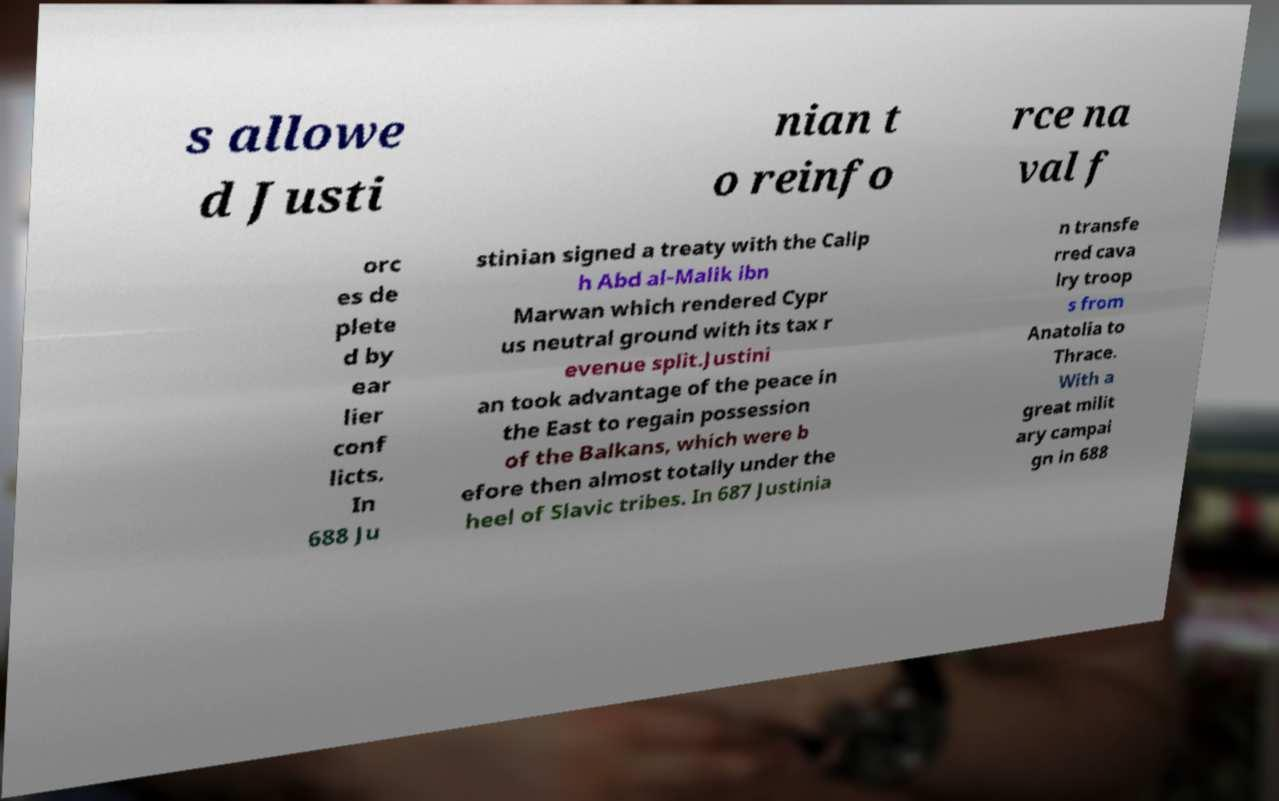There's text embedded in this image that I need extracted. Can you transcribe it verbatim? s allowe d Justi nian t o reinfo rce na val f orc es de plete d by ear lier conf licts. In 688 Ju stinian signed a treaty with the Calip h Abd al-Malik ibn Marwan which rendered Cypr us neutral ground with its tax r evenue split.Justini an took advantage of the peace in the East to regain possession of the Balkans, which were b efore then almost totally under the heel of Slavic tribes. In 687 Justinia n transfe rred cava lry troop s from Anatolia to Thrace. With a great milit ary campai gn in 688 